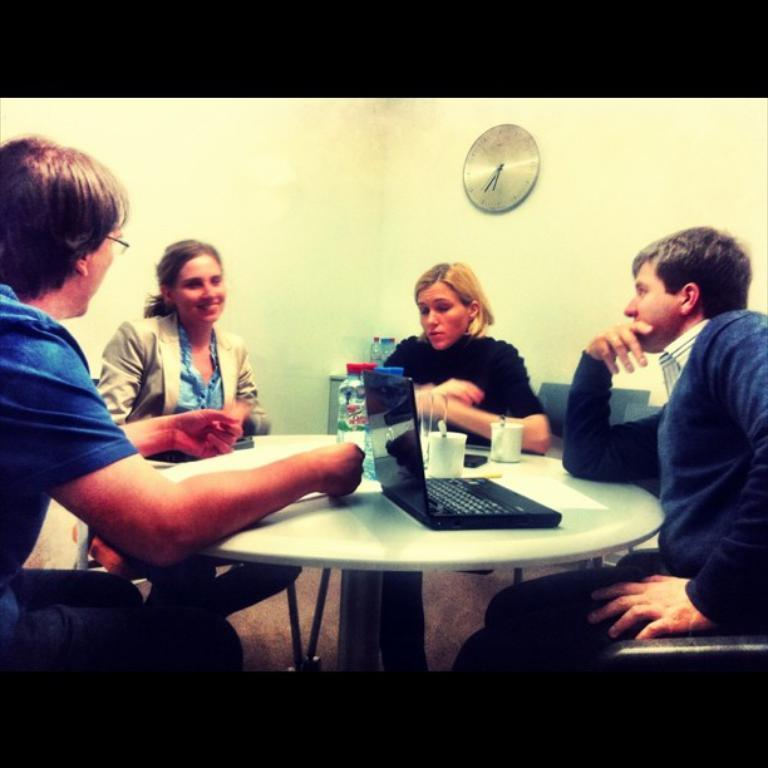How many people are in the image? There are four persons in the image. What are the four persons doing in the image? The four persons are sitting on a chair. What is in front of the persons? There is a table in front of them. What objects can be seen on the table? There is a laptop and a cup on the table. What can be seen on the wall in the image? There is a clock on the wall. How can the number of things on the table be increased in the image? The number of things on the table cannot be increased in the image, as the image is a static representation of the scene. 